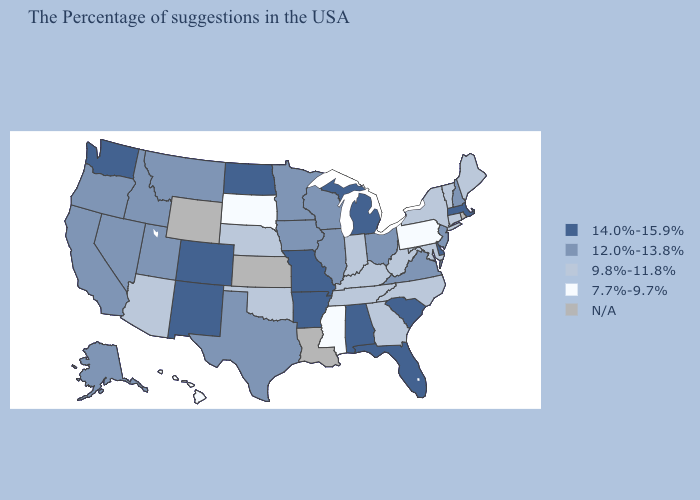What is the value of Alabama?
Be succinct. 14.0%-15.9%. Does Pennsylvania have the lowest value in the Northeast?
Answer briefly. Yes. Name the states that have a value in the range 12.0%-13.8%?
Quick response, please. New Hampshire, New Jersey, Virginia, Ohio, Wisconsin, Illinois, Minnesota, Iowa, Texas, Utah, Montana, Idaho, Nevada, California, Oregon, Alaska. Name the states that have a value in the range 9.8%-11.8%?
Concise answer only. Maine, Vermont, Connecticut, New York, Maryland, North Carolina, West Virginia, Georgia, Kentucky, Indiana, Tennessee, Nebraska, Oklahoma, Arizona. Name the states that have a value in the range 7.7%-9.7%?
Be succinct. Pennsylvania, Mississippi, South Dakota, Hawaii. Among the states that border New Mexico , which have the lowest value?
Concise answer only. Oklahoma, Arizona. Name the states that have a value in the range 7.7%-9.7%?
Be succinct. Pennsylvania, Mississippi, South Dakota, Hawaii. Does the first symbol in the legend represent the smallest category?
Give a very brief answer. No. Among the states that border West Virginia , does Pennsylvania have the lowest value?
Keep it brief. Yes. What is the highest value in the USA?
Short answer required. 14.0%-15.9%. Does Connecticut have the highest value in the Northeast?
Keep it brief. No. What is the lowest value in states that border Arizona?
Keep it brief. 12.0%-13.8%. Which states have the lowest value in the South?
Answer briefly. Mississippi. Name the states that have a value in the range 14.0%-15.9%?
Keep it brief. Massachusetts, Delaware, South Carolina, Florida, Michigan, Alabama, Missouri, Arkansas, North Dakota, Colorado, New Mexico, Washington. What is the value of Pennsylvania?
Keep it brief. 7.7%-9.7%. 